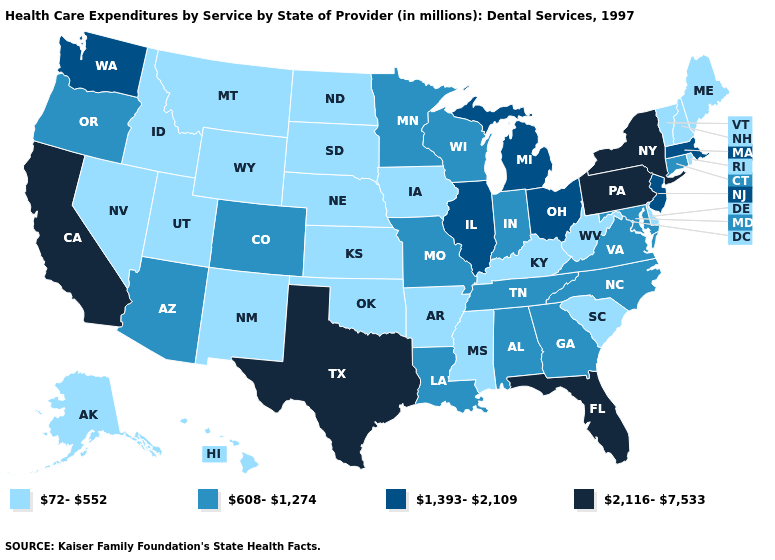Which states hav the highest value in the South?
Keep it brief. Florida, Texas. Does Utah have a higher value than Georgia?
Keep it brief. No. Does West Virginia have the lowest value in the South?
Be succinct. Yes. What is the value of Ohio?
Short answer required. 1,393-2,109. How many symbols are there in the legend?
Concise answer only. 4. Does the map have missing data?
Keep it brief. No. Does Missouri have the lowest value in the USA?
Concise answer only. No. Among the states that border Vermont , does Massachusetts have the highest value?
Be succinct. No. Among the states that border Mississippi , does Arkansas have the lowest value?
Write a very short answer. Yes. What is the value of North Dakota?
Be succinct. 72-552. Does Idaho have the highest value in the USA?
Give a very brief answer. No. What is the highest value in the USA?
Answer briefly. 2,116-7,533. Name the states that have a value in the range 2,116-7,533?
Write a very short answer. California, Florida, New York, Pennsylvania, Texas. Does Washington have the lowest value in the USA?
Be succinct. No. Among the states that border North Carolina , which have the lowest value?
Concise answer only. South Carolina. 